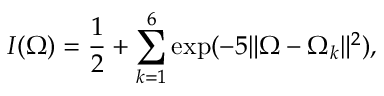Convert formula to latex. <formula><loc_0><loc_0><loc_500><loc_500>I ( \Omega ) = \frac { 1 } { 2 } + \sum _ { k = 1 } ^ { 6 } \exp ( - 5 \| \Omega - \Omega _ { k } \| ^ { 2 } ) ,</formula> 